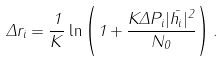Convert formula to latex. <formula><loc_0><loc_0><loc_500><loc_500>\Delta r _ { i } = \frac { 1 } { K } \ln \left ( 1 + \frac { K \Delta P _ { i } | \bar { h _ { i } } | ^ { 2 } } { N _ { 0 } } \right ) .</formula> 